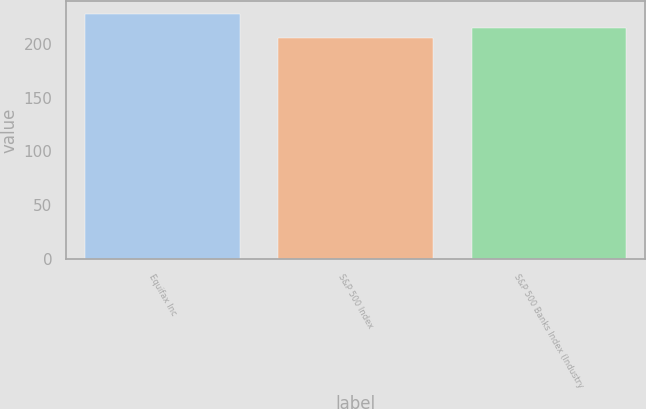<chart> <loc_0><loc_0><loc_500><loc_500><bar_chart><fcel>Equifax Inc<fcel>S&P 500 Index<fcel>S&P 500 Banks Index (Industry<nl><fcel>228.22<fcel>205.24<fcel>214.75<nl></chart> 